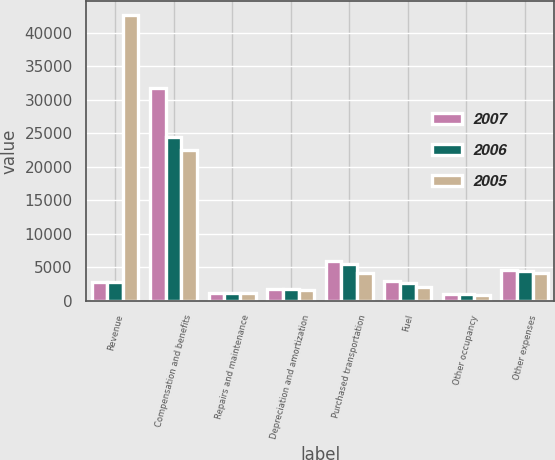Convert chart. <chart><loc_0><loc_0><loc_500><loc_500><stacked_bar_chart><ecel><fcel>Revenue<fcel>Compensation and benefits<fcel>Repairs and maintenance<fcel>Depreciation and amortization<fcel>Purchased transportation<fcel>Fuel<fcel>Other occupancy<fcel>Other expenses<nl><fcel>2007<fcel>2814.5<fcel>31745<fcel>1157<fcel>1745<fcel>5902<fcel>2974<fcel>958<fcel>4633<nl><fcel>2006<fcel>2814.5<fcel>24421<fcel>1155<fcel>1748<fcel>5496<fcel>2655<fcel>938<fcel>4499<nl><fcel>2005<fcel>42581<fcel>22517<fcel>1097<fcel>1644<fcel>4075<fcel>2085<fcel>872<fcel>4148<nl></chart> 